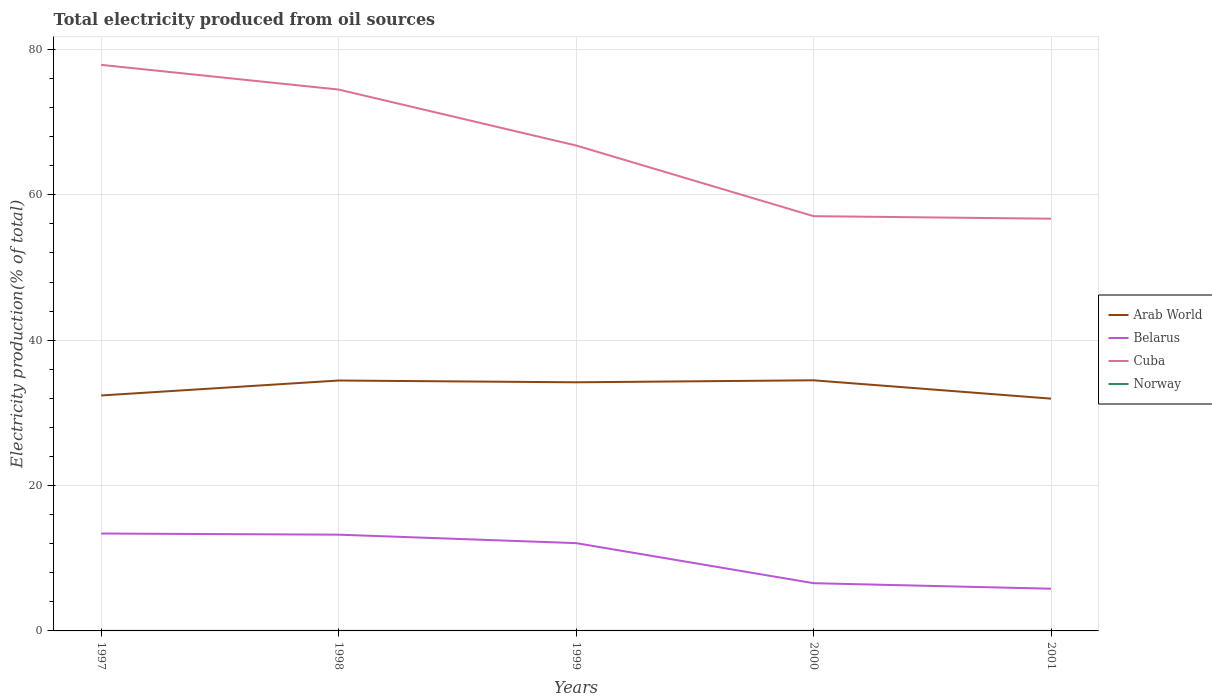Is the number of lines equal to the number of legend labels?
Offer a terse response. Yes. Across all years, what is the maximum total electricity produced in Cuba?
Give a very brief answer. 56.72. What is the total total electricity produced in Belarus in the graph?
Provide a short and direct response. 7.59. What is the difference between the highest and the second highest total electricity produced in Norway?
Offer a very short reply. 0. Is the total electricity produced in Cuba strictly greater than the total electricity produced in Arab World over the years?
Give a very brief answer. No. How many lines are there?
Offer a very short reply. 4. How many years are there in the graph?
Your response must be concise. 5. Does the graph contain grids?
Keep it short and to the point. Yes. Where does the legend appear in the graph?
Make the answer very short. Center right. How are the legend labels stacked?
Your answer should be compact. Vertical. What is the title of the graph?
Your response must be concise. Total electricity produced from oil sources. Does "Guinea" appear as one of the legend labels in the graph?
Provide a short and direct response. No. What is the Electricity production(% of total) in Arab World in 1997?
Provide a succinct answer. 32.4. What is the Electricity production(% of total) of Belarus in 1997?
Provide a succinct answer. 13.4. What is the Electricity production(% of total) of Cuba in 1997?
Your answer should be very brief. 77.88. What is the Electricity production(% of total) of Norway in 1997?
Keep it short and to the point. 0.01. What is the Electricity production(% of total) in Arab World in 1998?
Keep it short and to the point. 34.45. What is the Electricity production(% of total) of Belarus in 1998?
Your answer should be compact. 13.24. What is the Electricity production(% of total) of Cuba in 1998?
Give a very brief answer. 74.48. What is the Electricity production(% of total) in Norway in 1998?
Offer a terse response. 0.01. What is the Electricity production(% of total) of Arab World in 1999?
Provide a succinct answer. 34.21. What is the Electricity production(% of total) of Belarus in 1999?
Your answer should be compact. 12.08. What is the Electricity production(% of total) of Cuba in 1999?
Your answer should be compact. 66.79. What is the Electricity production(% of total) in Norway in 1999?
Offer a very short reply. 0.01. What is the Electricity production(% of total) of Arab World in 2000?
Make the answer very short. 34.48. What is the Electricity production(% of total) in Belarus in 2000?
Your response must be concise. 6.57. What is the Electricity production(% of total) of Cuba in 2000?
Provide a short and direct response. 57.06. What is the Electricity production(% of total) in Norway in 2000?
Keep it short and to the point. 0.01. What is the Electricity production(% of total) of Arab World in 2001?
Ensure brevity in your answer.  31.96. What is the Electricity production(% of total) of Belarus in 2001?
Offer a very short reply. 5.81. What is the Electricity production(% of total) of Cuba in 2001?
Offer a terse response. 56.72. What is the Electricity production(% of total) in Norway in 2001?
Provide a succinct answer. 0.01. Across all years, what is the maximum Electricity production(% of total) in Arab World?
Your answer should be compact. 34.48. Across all years, what is the maximum Electricity production(% of total) in Belarus?
Make the answer very short. 13.4. Across all years, what is the maximum Electricity production(% of total) in Cuba?
Make the answer very short. 77.88. Across all years, what is the maximum Electricity production(% of total) of Norway?
Your answer should be very brief. 0.01. Across all years, what is the minimum Electricity production(% of total) in Arab World?
Make the answer very short. 31.96. Across all years, what is the minimum Electricity production(% of total) in Belarus?
Give a very brief answer. 5.81. Across all years, what is the minimum Electricity production(% of total) in Cuba?
Provide a succinct answer. 56.72. Across all years, what is the minimum Electricity production(% of total) of Norway?
Your answer should be very brief. 0.01. What is the total Electricity production(% of total) in Arab World in the graph?
Your answer should be very brief. 167.5. What is the total Electricity production(% of total) in Belarus in the graph?
Give a very brief answer. 51.1. What is the total Electricity production(% of total) in Cuba in the graph?
Offer a very short reply. 332.93. What is the total Electricity production(% of total) in Norway in the graph?
Offer a terse response. 0.04. What is the difference between the Electricity production(% of total) of Arab World in 1997 and that in 1998?
Offer a terse response. -2.06. What is the difference between the Electricity production(% of total) of Belarus in 1997 and that in 1998?
Ensure brevity in your answer.  0.16. What is the difference between the Electricity production(% of total) of Cuba in 1997 and that in 1998?
Ensure brevity in your answer.  3.4. What is the difference between the Electricity production(% of total) of Norway in 1997 and that in 1998?
Keep it short and to the point. 0. What is the difference between the Electricity production(% of total) in Arab World in 1997 and that in 1999?
Your response must be concise. -1.81. What is the difference between the Electricity production(% of total) of Belarus in 1997 and that in 1999?
Ensure brevity in your answer.  1.32. What is the difference between the Electricity production(% of total) in Cuba in 1997 and that in 1999?
Your answer should be very brief. 11.09. What is the difference between the Electricity production(% of total) of Norway in 1997 and that in 1999?
Offer a very short reply. -0. What is the difference between the Electricity production(% of total) in Arab World in 1997 and that in 2000?
Make the answer very short. -2.09. What is the difference between the Electricity production(% of total) in Belarus in 1997 and that in 2000?
Ensure brevity in your answer.  6.83. What is the difference between the Electricity production(% of total) in Cuba in 1997 and that in 2000?
Keep it short and to the point. 20.82. What is the difference between the Electricity production(% of total) of Norway in 1997 and that in 2000?
Provide a short and direct response. 0. What is the difference between the Electricity production(% of total) in Arab World in 1997 and that in 2001?
Offer a very short reply. 0.44. What is the difference between the Electricity production(% of total) in Belarus in 1997 and that in 2001?
Give a very brief answer. 7.59. What is the difference between the Electricity production(% of total) of Cuba in 1997 and that in 2001?
Offer a terse response. 21.16. What is the difference between the Electricity production(% of total) of Norway in 1997 and that in 2001?
Give a very brief answer. -0. What is the difference between the Electricity production(% of total) of Arab World in 1998 and that in 1999?
Provide a succinct answer. 0.25. What is the difference between the Electricity production(% of total) in Belarus in 1998 and that in 1999?
Make the answer very short. 1.16. What is the difference between the Electricity production(% of total) of Cuba in 1998 and that in 1999?
Offer a very short reply. 7.7. What is the difference between the Electricity production(% of total) of Norway in 1998 and that in 1999?
Provide a short and direct response. -0. What is the difference between the Electricity production(% of total) of Arab World in 1998 and that in 2000?
Give a very brief answer. -0.03. What is the difference between the Electricity production(% of total) of Belarus in 1998 and that in 2000?
Offer a very short reply. 6.68. What is the difference between the Electricity production(% of total) of Cuba in 1998 and that in 2000?
Your answer should be very brief. 17.42. What is the difference between the Electricity production(% of total) of Norway in 1998 and that in 2000?
Provide a short and direct response. -0. What is the difference between the Electricity production(% of total) of Arab World in 1998 and that in 2001?
Give a very brief answer. 2.5. What is the difference between the Electricity production(% of total) of Belarus in 1998 and that in 2001?
Your answer should be very brief. 7.43. What is the difference between the Electricity production(% of total) in Cuba in 1998 and that in 2001?
Provide a succinct answer. 17.77. What is the difference between the Electricity production(% of total) of Norway in 1998 and that in 2001?
Offer a very short reply. -0. What is the difference between the Electricity production(% of total) of Arab World in 1999 and that in 2000?
Provide a short and direct response. -0.27. What is the difference between the Electricity production(% of total) of Belarus in 1999 and that in 2000?
Your response must be concise. 5.51. What is the difference between the Electricity production(% of total) in Cuba in 1999 and that in 2000?
Give a very brief answer. 9.72. What is the difference between the Electricity production(% of total) of Norway in 1999 and that in 2000?
Provide a short and direct response. 0. What is the difference between the Electricity production(% of total) in Arab World in 1999 and that in 2001?
Provide a succinct answer. 2.25. What is the difference between the Electricity production(% of total) of Belarus in 1999 and that in 2001?
Ensure brevity in your answer.  6.27. What is the difference between the Electricity production(% of total) of Cuba in 1999 and that in 2001?
Ensure brevity in your answer.  10.07. What is the difference between the Electricity production(% of total) in Norway in 1999 and that in 2001?
Ensure brevity in your answer.  0. What is the difference between the Electricity production(% of total) in Arab World in 2000 and that in 2001?
Keep it short and to the point. 2.52. What is the difference between the Electricity production(% of total) in Belarus in 2000 and that in 2001?
Your response must be concise. 0.76. What is the difference between the Electricity production(% of total) in Cuba in 2000 and that in 2001?
Provide a succinct answer. 0.35. What is the difference between the Electricity production(% of total) of Norway in 2000 and that in 2001?
Offer a terse response. -0. What is the difference between the Electricity production(% of total) of Arab World in 1997 and the Electricity production(% of total) of Belarus in 1998?
Provide a short and direct response. 19.15. What is the difference between the Electricity production(% of total) of Arab World in 1997 and the Electricity production(% of total) of Cuba in 1998?
Ensure brevity in your answer.  -42.09. What is the difference between the Electricity production(% of total) in Arab World in 1997 and the Electricity production(% of total) in Norway in 1998?
Your answer should be compact. 32.39. What is the difference between the Electricity production(% of total) in Belarus in 1997 and the Electricity production(% of total) in Cuba in 1998?
Give a very brief answer. -61.08. What is the difference between the Electricity production(% of total) in Belarus in 1997 and the Electricity production(% of total) in Norway in 1998?
Your answer should be very brief. 13.4. What is the difference between the Electricity production(% of total) in Cuba in 1997 and the Electricity production(% of total) in Norway in 1998?
Keep it short and to the point. 77.87. What is the difference between the Electricity production(% of total) in Arab World in 1997 and the Electricity production(% of total) in Belarus in 1999?
Offer a terse response. 20.32. What is the difference between the Electricity production(% of total) of Arab World in 1997 and the Electricity production(% of total) of Cuba in 1999?
Give a very brief answer. -34.39. What is the difference between the Electricity production(% of total) of Arab World in 1997 and the Electricity production(% of total) of Norway in 1999?
Ensure brevity in your answer.  32.39. What is the difference between the Electricity production(% of total) of Belarus in 1997 and the Electricity production(% of total) of Cuba in 1999?
Provide a succinct answer. -53.39. What is the difference between the Electricity production(% of total) in Belarus in 1997 and the Electricity production(% of total) in Norway in 1999?
Make the answer very short. 13.39. What is the difference between the Electricity production(% of total) of Cuba in 1997 and the Electricity production(% of total) of Norway in 1999?
Ensure brevity in your answer.  77.87. What is the difference between the Electricity production(% of total) in Arab World in 1997 and the Electricity production(% of total) in Belarus in 2000?
Make the answer very short. 25.83. What is the difference between the Electricity production(% of total) of Arab World in 1997 and the Electricity production(% of total) of Cuba in 2000?
Offer a very short reply. -24.67. What is the difference between the Electricity production(% of total) in Arab World in 1997 and the Electricity production(% of total) in Norway in 2000?
Provide a short and direct response. 32.39. What is the difference between the Electricity production(% of total) of Belarus in 1997 and the Electricity production(% of total) of Cuba in 2000?
Your response must be concise. -43.66. What is the difference between the Electricity production(% of total) in Belarus in 1997 and the Electricity production(% of total) in Norway in 2000?
Your answer should be very brief. 13.4. What is the difference between the Electricity production(% of total) of Cuba in 1997 and the Electricity production(% of total) of Norway in 2000?
Offer a terse response. 77.87. What is the difference between the Electricity production(% of total) of Arab World in 1997 and the Electricity production(% of total) of Belarus in 2001?
Ensure brevity in your answer.  26.59. What is the difference between the Electricity production(% of total) of Arab World in 1997 and the Electricity production(% of total) of Cuba in 2001?
Give a very brief answer. -24.32. What is the difference between the Electricity production(% of total) of Arab World in 1997 and the Electricity production(% of total) of Norway in 2001?
Ensure brevity in your answer.  32.39. What is the difference between the Electricity production(% of total) of Belarus in 1997 and the Electricity production(% of total) of Cuba in 2001?
Offer a terse response. -43.31. What is the difference between the Electricity production(% of total) of Belarus in 1997 and the Electricity production(% of total) of Norway in 2001?
Your answer should be very brief. 13.39. What is the difference between the Electricity production(% of total) in Cuba in 1997 and the Electricity production(% of total) in Norway in 2001?
Your answer should be compact. 77.87. What is the difference between the Electricity production(% of total) of Arab World in 1998 and the Electricity production(% of total) of Belarus in 1999?
Your response must be concise. 22.37. What is the difference between the Electricity production(% of total) in Arab World in 1998 and the Electricity production(% of total) in Cuba in 1999?
Offer a terse response. -32.34. What is the difference between the Electricity production(% of total) in Arab World in 1998 and the Electricity production(% of total) in Norway in 1999?
Provide a short and direct response. 34.45. What is the difference between the Electricity production(% of total) in Belarus in 1998 and the Electricity production(% of total) in Cuba in 1999?
Your answer should be very brief. -53.55. What is the difference between the Electricity production(% of total) of Belarus in 1998 and the Electricity production(% of total) of Norway in 1999?
Provide a short and direct response. 13.23. What is the difference between the Electricity production(% of total) in Cuba in 1998 and the Electricity production(% of total) in Norway in 1999?
Offer a terse response. 74.48. What is the difference between the Electricity production(% of total) in Arab World in 1998 and the Electricity production(% of total) in Belarus in 2000?
Your answer should be compact. 27.89. What is the difference between the Electricity production(% of total) in Arab World in 1998 and the Electricity production(% of total) in Cuba in 2000?
Ensure brevity in your answer.  -22.61. What is the difference between the Electricity production(% of total) of Arab World in 1998 and the Electricity production(% of total) of Norway in 2000?
Give a very brief answer. 34.45. What is the difference between the Electricity production(% of total) of Belarus in 1998 and the Electricity production(% of total) of Cuba in 2000?
Keep it short and to the point. -43.82. What is the difference between the Electricity production(% of total) in Belarus in 1998 and the Electricity production(% of total) in Norway in 2000?
Your answer should be very brief. 13.24. What is the difference between the Electricity production(% of total) in Cuba in 1998 and the Electricity production(% of total) in Norway in 2000?
Make the answer very short. 74.48. What is the difference between the Electricity production(% of total) of Arab World in 1998 and the Electricity production(% of total) of Belarus in 2001?
Offer a very short reply. 28.64. What is the difference between the Electricity production(% of total) in Arab World in 1998 and the Electricity production(% of total) in Cuba in 2001?
Provide a succinct answer. -22.26. What is the difference between the Electricity production(% of total) of Arab World in 1998 and the Electricity production(% of total) of Norway in 2001?
Give a very brief answer. 34.45. What is the difference between the Electricity production(% of total) in Belarus in 1998 and the Electricity production(% of total) in Cuba in 2001?
Your response must be concise. -43.47. What is the difference between the Electricity production(% of total) in Belarus in 1998 and the Electricity production(% of total) in Norway in 2001?
Ensure brevity in your answer.  13.24. What is the difference between the Electricity production(% of total) of Cuba in 1998 and the Electricity production(% of total) of Norway in 2001?
Offer a terse response. 74.48. What is the difference between the Electricity production(% of total) in Arab World in 1999 and the Electricity production(% of total) in Belarus in 2000?
Your response must be concise. 27.64. What is the difference between the Electricity production(% of total) of Arab World in 1999 and the Electricity production(% of total) of Cuba in 2000?
Provide a short and direct response. -22.86. What is the difference between the Electricity production(% of total) of Arab World in 1999 and the Electricity production(% of total) of Norway in 2000?
Your answer should be compact. 34.2. What is the difference between the Electricity production(% of total) in Belarus in 1999 and the Electricity production(% of total) in Cuba in 2000?
Your response must be concise. -44.99. What is the difference between the Electricity production(% of total) of Belarus in 1999 and the Electricity production(% of total) of Norway in 2000?
Your response must be concise. 12.07. What is the difference between the Electricity production(% of total) in Cuba in 1999 and the Electricity production(% of total) in Norway in 2000?
Keep it short and to the point. 66.78. What is the difference between the Electricity production(% of total) of Arab World in 1999 and the Electricity production(% of total) of Belarus in 2001?
Your answer should be compact. 28.4. What is the difference between the Electricity production(% of total) in Arab World in 1999 and the Electricity production(% of total) in Cuba in 2001?
Make the answer very short. -22.51. What is the difference between the Electricity production(% of total) of Arab World in 1999 and the Electricity production(% of total) of Norway in 2001?
Provide a short and direct response. 34.2. What is the difference between the Electricity production(% of total) of Belarus in 1999 and the Electricity production(% of total) of Cuba in 2001?
Give a very brief answer. -44.64. What is the difference between the Electricity production(% of total) of Belarus in 1999 and the Electricity production(% of total) of Norway in 2001?
Give a very brief answer. 12.07. What is the difference between the Electricity production(% of total) of Cuba in 1999 and the Electricity production(% of total) of Norway in 2001?
Make the answer very short. 66.78. What is the difference between the Electricity production(% of total) of Arab World in 2000 and the Electricity production(% of total) of Belarus in 2001?
Your answer should be very brief. 28.67. What is the difference between the Electricity production(% of total) of Arab World in 2000 and the Electricity production(% of total) of Cuba in 2001?
Provide a succinct answer. -22.23. What is the difference between the Electricity production(% of total) of Arab World in 2000 and the Electricity production(% of total) of Norway in 2001?
Ensure brevity in your answer.  34.47. What is the difference between the Electricity production(% of total) in Belarus in 2000 and the Electricity production(% of total) in Cuba in 2001?
Offer a terse response. -50.15. What is the difference between the Electricity production(% of total) in Belarus in 2000 and the Electricity production(% of total) in Norway in 2001?
Provide a short and direct response. 6.56. What is the difference between the Electricity production(% of total) in Cuba in 2000 and the Electricity production(% of total) in Norway in 2001?
Offer a very short reply. 57.06. What is the average Electricity production(% of total) of Arab World per year?
Offer a terse response. 33.5. What is the average Electricity production(% of total) of Belarus per year?
Offer a very short reply. 10.22. What is the average Electricity production(% of total) in Cuba per year?
Ensure brevity in your answer.  66.59. What is the average Electricity production(% of total) of Norway per year?
Offer a very short reply. 0.01. In the year 1997, what is the difference between the Electricity production(% of total) of Arab World and Electricity production(% of total) of Belarus?
Make the answer very short. 19. In the year 1997, what is the difference between the Electricity production(% of total) of Arab World and Electricity production(% of total) of Cuba?
Give a very brief answer. -45.48. In the year 1997, what is the difference between the Electricity production(% of total) in Arab World and Electricity production(% of total) in Norway?
Offer a very short reply. 32.39. In the year 1997, what is the difference between the Electricity production(% of total) of Belarus and Electricity production(% of total) of Cuba?
Your response must be concise. -64.48. In the year 1997, what is the difference between the Electricity production(% of total) of Belarus and Electricity production(% of total) of Norway?
Give a very brief answer. 13.39. In the year 1997, what is the difference between the Electricity production(% of total) of Cuba and Electricity production(% of total) of Norway?
Your response must be concise. 77.87. In the year 1998, what is the difference between the Electricity production(% of total) in Arab World and Electricity production(% of total) in Belarus?
Your answer should be very brief. 21.21. In the year 1998, what is the difference between the Electricity production(% of total) in Arab World and Electricity production(% of total) in Cuba?
Provide a short and direct response. -40.03. In the year 1998, what is the difference between the Electricity production(% of total) in Arab World and Electricity production(% of total) in Norway?
Your answer should be very brief. 34.45. In the year 1998, what is the difference between the Electricity production(% of total) of Belarus and Electricity production(% of total) of Cuba?
Offer a very short reply. -61.24. In the year 1998, what is the difference between the Electricity production(% of total) in Belarus and Electricity production(% of total) in Norway?
Provide a short and direct response. 13.24. In the year 1998, what is the difference between the Electricity production(% of total) of Cuba and Electricity production(% of total) of Norway?
Ensure brevity in your answer.  74.48. In the year 1999, what is the difference between the Electricity production(% of total) of Arab World and Electricity production(% of total) of Belarus?
Offer a very short reply. 22.13. In the year 1999, what is the difference between the Electricity production(% of total) in Arab World and Electricity production(% of total) in Cuba?
Ensure brevity in your answer.  -32.58. In the year 1999, what is the difference between the Electricity production(% of total) of Arab World and Electricity production(% of total) of Norway?
Keep it short and to the point. 34.2. In the year 1999, what is the difference between the Electricity production(% of total) of Belarus and Electricity production(% of total) of Cuba?
Provide a succinct answer. -54.71. In the year 1999, what is the difference between the Electricity production(% of total) in Belarus and Electricity production(% of total) in Norway?
Your answer should be very brief. 12.07. In the year 1999, what is the difference between the Electricity production(% of total) of Cuba and Electricity production(% of total) of Norway?
Give a very brief answer. 66.78. In the year 2000, what is the difference between the Electricity production(% of total) in Arab World and Electricity production(% of total) in Belarus?
Make the answer very short. 27.91. In the year 2000, what is the difference between the Electricity production(% of total) of Arab World and Electricity production(% of total) of Cuba?
Your answer should be very brief. -22.58. In the year 2000, what is the difference between the Electricity production(% of total) of Arab World and Electricity production(% of total) of Norway?
Offer a very short reply. 34.48. In the year 2000, what is the difference between the Electricity production(% of total) of Belarus and Electricity production(% of total) of Cuba?
Your response must be concise. -50.5. In the year 2000, what is the difference between the Electricity production(% of total) in Belarus and Electricity production(% of total) in Norway?
Provide a short and direct response. 6.56. In the year 2000, what is the difference between the Electricity production(% of total) of Cuba and Electricity production(% of total) of Norway?
Provide a succinct answer. 57.06. In the year 2001, what is the difference between the Electricity production(% of total) in Arab World and Electricity production(% of total) in Belarus?
Provide a succinct answer. 26.15. In the year 2001, what is the difference between the Electricity production(% of total) in Arab World and Electricity production(% of total) in Cuba?
Ensure brevity in your answer.  -24.76. In the year 2001, what is the difference between the Electricity production(% of total) of Arab World and Electricity production(% of total) of Norway?
Make the answer very short. 31.95. In the year 2001, what is the difference between the Electricity production(% of total) of Belarus and Electricity production(% of total) of Cuba?
Ensure brevity in your answer.  -50.91. In the year 2001, what is the difference between the Electricity production(% of total) in Belarus and Electricity production(% of total) in Norway?
Your answer should be very brief. 5.8. In the year 2001, what is the difference between the Electricity production(% of total) in Cuba and Electricity production(% of total) in Norway?
Make the answer very short. 56.71. What is the ratio of the Electricity production(% of total) of Arab World in 1997 to that in 1998?
Give a very brief answer. 0.94. What is the ratio of the Electricity production(% of total) in Belarus in 1997 to that in 1998?
Make the answer very short. 1.01. What is the ratio of the Electricity production(% of total) of Cuba in 1997 to that in 1998?
Keep it short and to the point. 1.05. What is the ratio of the Electricity production(% of total) in Norway in 1997 to that in 1998?
Your response must be concise. 1.2. What is the ratio of the Electricity production(% of total) of Arab World in 1997 to that in 1999?
Keep it short and to the point. 0.95. What is the ratio of the Electricity production(% of total) of Belarus in 1997 to that in 1999?
Ensure brevity in your answer.  1.11. What is the ratio of the Electricity production(% of total) of Cuba in 1997 to that in 1999?
Your response must be concise. 1.17. What is the ratio of the Electricity production(% of total) in Norway in 1997 to that in 1999?
Give a very brief answer. 0.89. What is the ratio of the Electricity production(% of total) in Arab World in 1997 to that in 2000?
Offer a very short reply. 0.94. What is the ratio of the Electricity production(% of total) of Belarus in 1997 to that in 2000?
Your answer should be compact. 2.04. What is the ratio of the Electricity production(% of total) in Cuba in 1997 to that in 2000?
Your answer should be compact. 1.36. What is the ratio of the Electricity production(% of total) of Norway in 1997 to that in 2000?
Give a very brief answer. 1.15. What is the ratio of the Electricity production(% of total) in Arab World in 1997 to that in 2001?
Make the answer very short. 1.01. What is the ratio of the Electricity production(% of total) in Belarus in 1997 to that in 2001?
Make the answer very short. 2.31. What is the ratio of the Electricity production(% of total) in Cuba in 1997 to that in 2001?
Make the answer very short. 1.37. What is the ratio of the Electricity production(% of total) in Norway in 1997 to that in 2001?
Give a very brief answer. 0.98. What is the ratio of the Electricity production(% of total) of Belarus in 1998 to that in 1999?
Provide a short and direct response. 1.1. What is the ratio of the Electricity production(% of total) of Cuba in 1998 to that in 1999?
Make the answer very short. 1.12. What is the ratio of the Electricity production(% of total) in Norway in 1998 to that in 1999?
Offer a very short reply. 0.74. What is the ratio of the Electricity production(% of total) of Belarus in 1998 to that in 2000?
Provide a succinct answer. 2.02. What is the ratio of the Electricity production(% of total) of Cuba in 1998 to that in 2000?
Keep it short and to the point. 1.31. What is the ratio of the Electricity production(% of total) in Norway in 1998 to that in 2000?
Your response must be concise. 0.95. What is the ratio of the Electricity production(% of total) of Arab World in 1998 to that in 2001?
Your answer should be compact. 1.08. What is the ratio of the Electricity production(% of total) of Belarus in 1998 to that in 2001?
Offer a terse response. 2.28. What is the ratio of the Electricity production(% of total) of Cuba in 1998 to that in 2001?
Provide a succinct answer. 1.31. What is the ratio of the Electricity production(% of total) in Norway in 1998 to that in 2001?
Provide a short and direct response. 0.81. What is the ratio of the Electricity production(% of total) of Belarus in 1999 to that in 2000?
Offer a terse response. 1.84. What is the ratio of the Electricity production(% of total) of Cuba in 1999 to that in 2000?
Provide a short and direct response. 1.17. What is the ratio of the Electricity production(% of total) in Norway in 1999 to that in 2000?
Make the answer very short. 1.29. What is the ratio of the Electricity production(% of total) in Arab World in 1999 to that in 2001?
Make the answer very short. 1.07. What is the ratio of the Electricity production(% of total) of Belarus in 1999 to that in 2001?
Your response must be concise. 2.08. What is the ratio of the Electricity production(% of total) in Cuba in 1999 to that in 2001?
Your answer should be very brief. 1.18. What is the ratio of the Electricity production(% of total) in Norway in 1999 to that in 2001?
Offer a terse response. 1.1. What is the ratio of the Electricity production(% of total) of Arab World in 2000 to that in 2001?
Keep it short and to the point. 1.08. What is the ratio of the Electricity production(% of total) of Belarus in 2000 to that in 2001?
Make the answer very short. 1.13. What is the ratio of the Electricity production(% of total) of Cuba in 2000 to that in 2001?
Provide a succinct answer. 1.01. What is the ratio of the Electricity production(% of total) in Norway in 2000 to that in 2001?
Offer a very short reply. 0.85. What is the difference between the highest and the second highest Electricity production(% of total) in Arab World?
Offer a very short reply. 0.03. What is the difference between the highest and the second highest Electricity production(% of total) of Belarus?
Your answer should be compact. 0.16. What is the difference between the highest and the second highest Electricity production(% of total) in Cuba?
Offer a terse response. 3.4. What is the difference between the highest and the second highest Electricity production(% of total) in Norway?
Your answer should be compact. 0. What is the difference between the highest and the lowest Electricity production(% of total) of Arab World?
Offer a terse response. 2.52. What is the difference between the highest and the lowest Electricity production(% of total) of Belarus?
Give a very brief answer. 7.59. What is the difference between the highest and the lowest Electricity production(% of total) of Cuba?
Give a very brief answer. 21.16. What is the difference between the highest and the lowest Electricity production(% of total) in Norway?
Your answer should be compact. 0. 